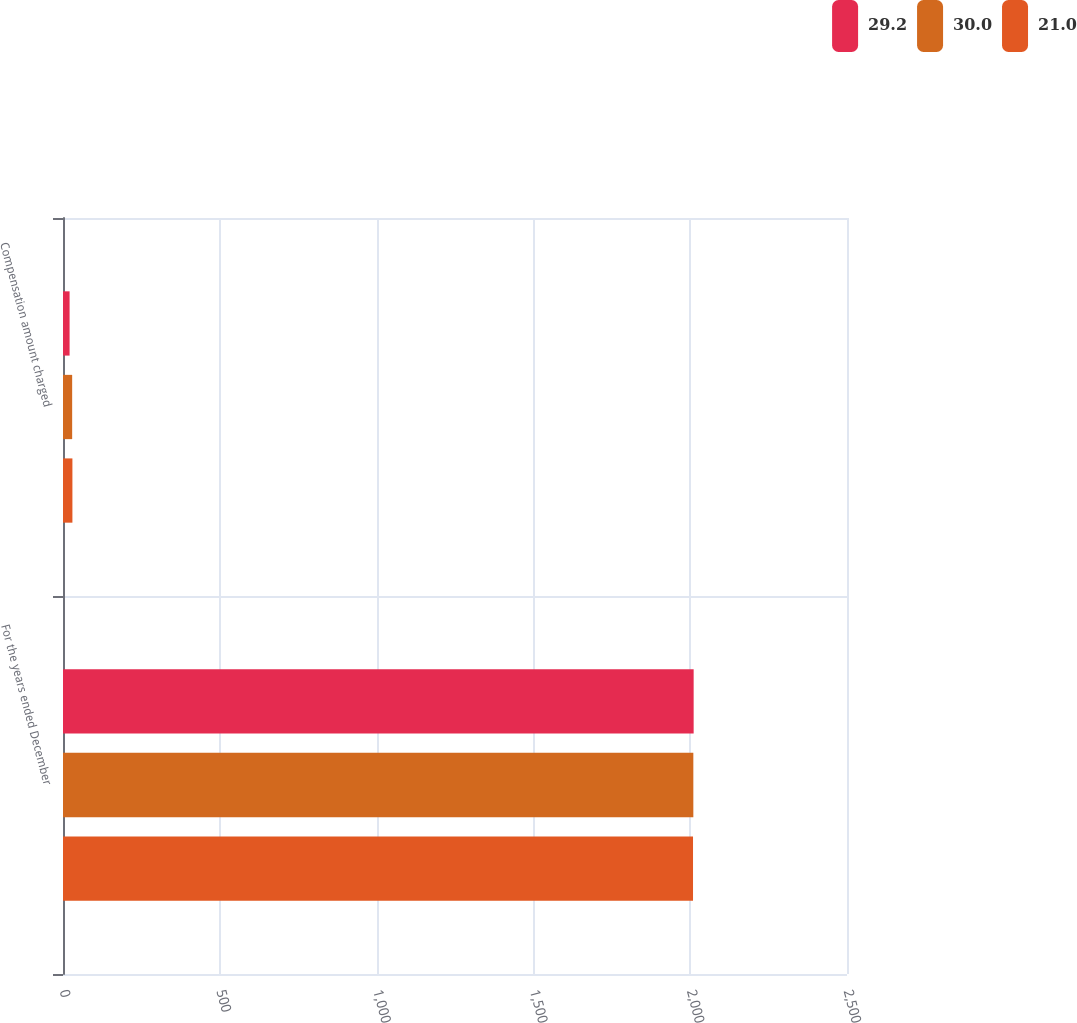<chart> <loc_0><loc_0><loc_500><loc_500><stacked_bar_chart><ecel><fcel>For the years ended December<fcel>Compensation amount charged<nl><fcel>29.2<fcel>2011<fcel>21<nl><fcel>30<fcel>2010<fcel>29.2<nl><fcel>21<fcel>2009<fcel>30<nl></chart> 